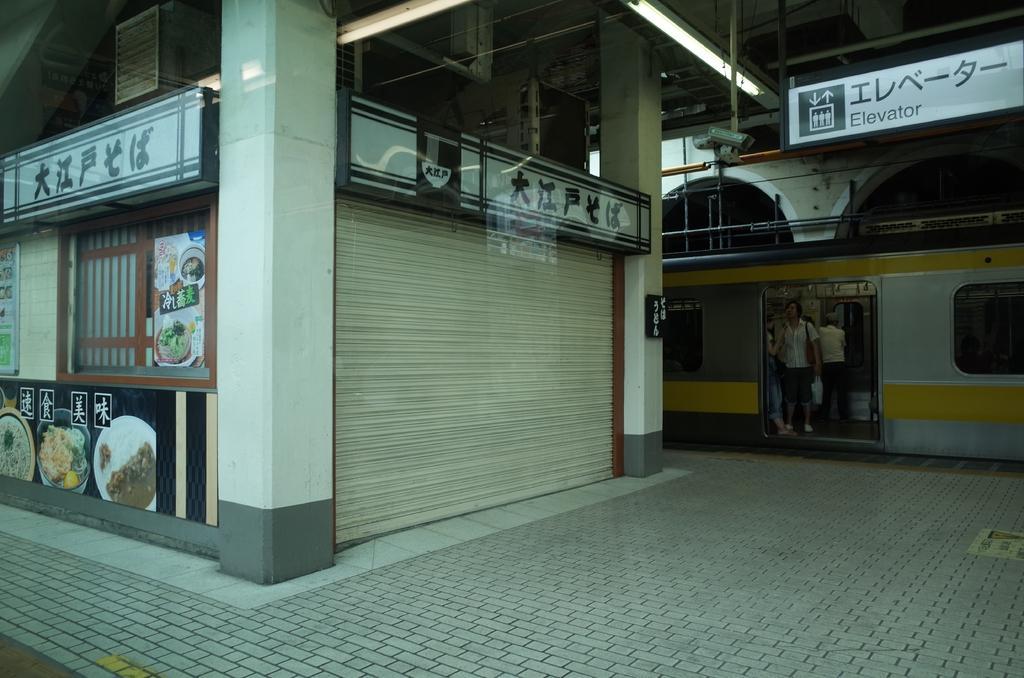In one or two sentences, can you explain what this image depicts? In this picture we can see a train here, there are some people standing in the train, there is a hoarding here, we can see lights here, we can see shutter here. 